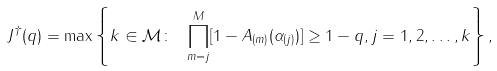Convert formula to latex. <formula><loc_0><loc_0><loc_500><loc_500>J ^ { \dagger } ( q ) = \max \left \{ k \in \mathcal { M } \colon \ \prod _ { m = j } ^ { M } [ 1 - A _ { ( m ) } ( \alpha _ { ( j ) } ) ] \geq 1 - q , j = 1 , 2 , \dots , k \right \} ,</formula> 